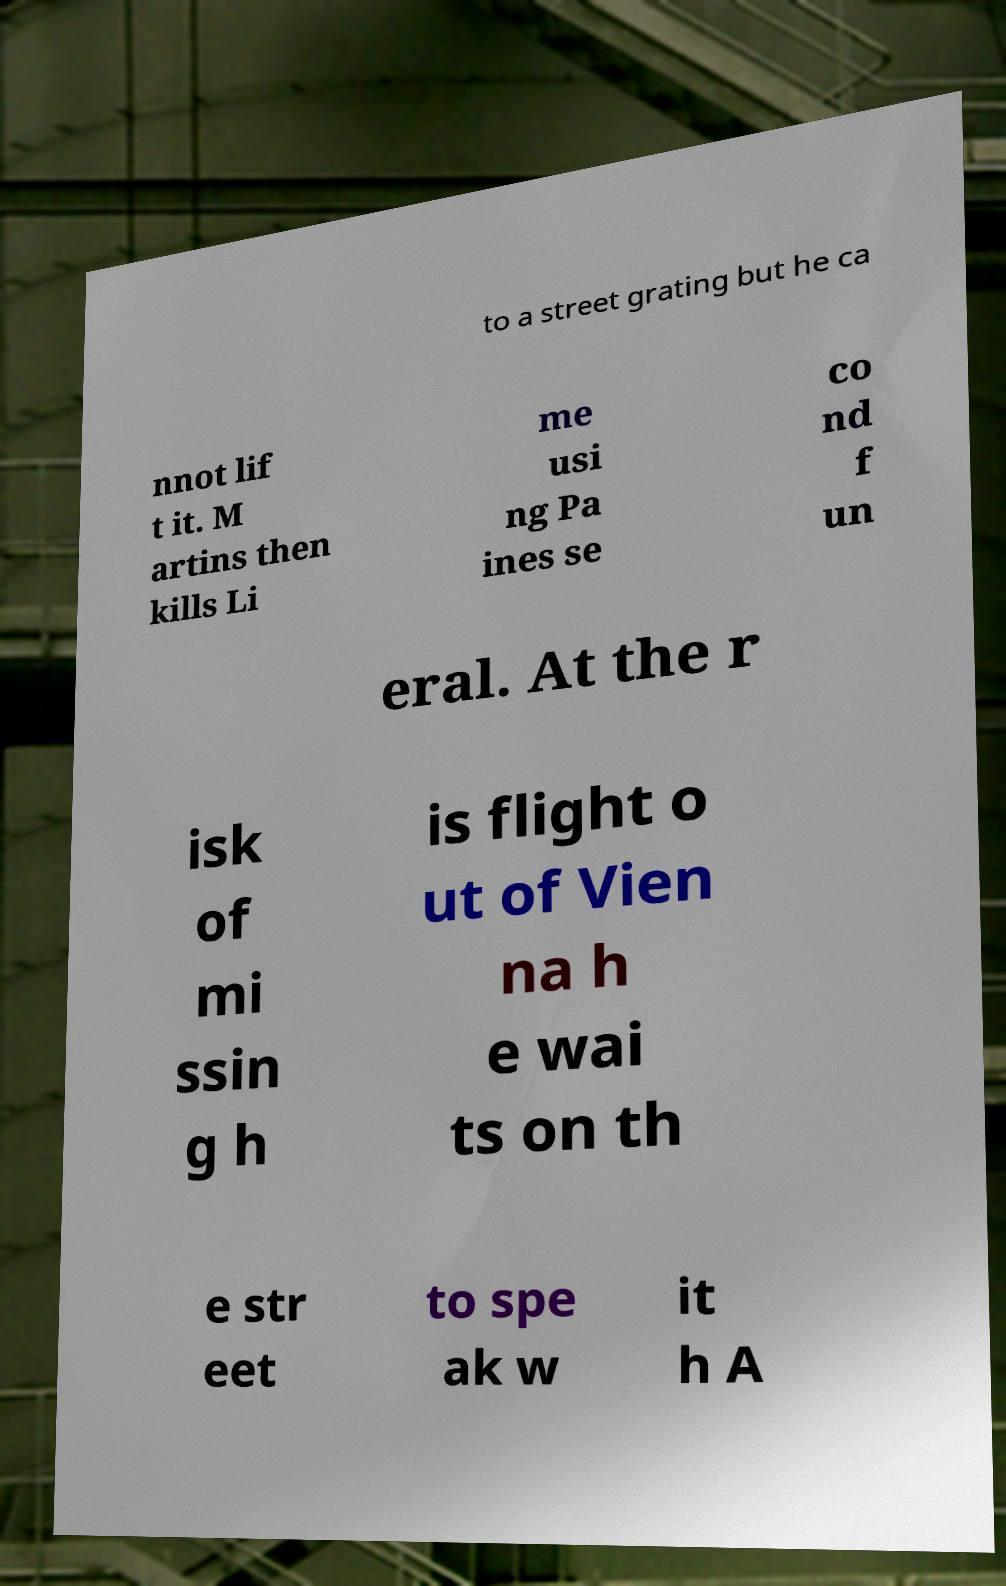For documentation purposes, I need the text within this image transcribed. Could you provide that? to a street grating but he ca nnot lif t it. M artins then kills Li me usi ng Pa ines se co nd f un eral. At the r isk of mi ssin g h is flight o ut of Vien na h e wai ts on th e str eet to spe ak w it h A 